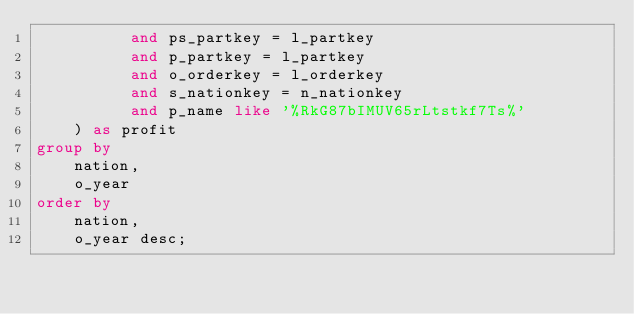Convert code to text. <code><loc_0><loc_0><loc_500><loc_500><_SQL_>          and ps_partkey = l_partkey
          and p_partkey = l_partkey
          and o_orderkey = l_orderkey
          and s_nationkey = n_nationkey
          and p_name like '%RkG87bIMUV65rLtstkf7Ts%'
    ) as profit
group by
    nation,
    o_year
order by
    nation,
    o_year desc;
</code> 